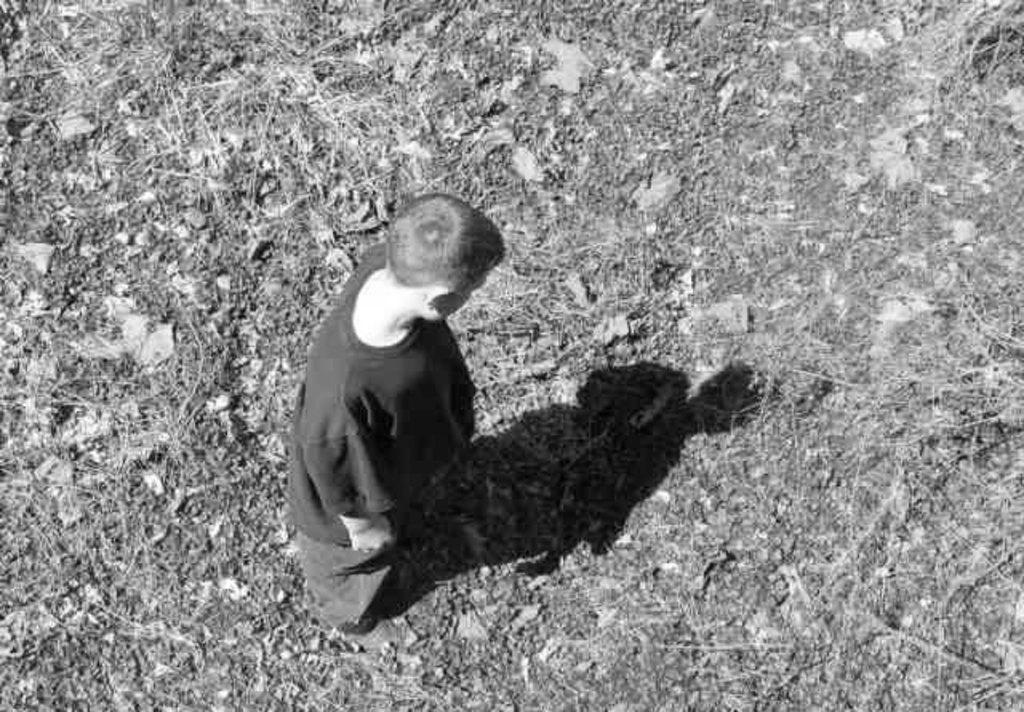What is the main subject in the image? There is a person standing in the image. What can be seen at the bottom of the image? There are dry leaves and grass at the bottom of the image. What type of expansion is taking place in the town shown in the image? There is no town or expansion present in the image; it only features a person standing and dry leaves and grass at the bottom. 